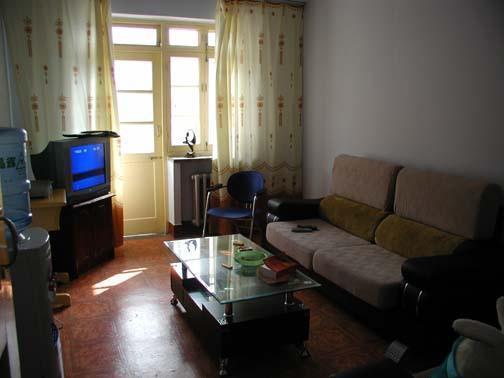How many chairs can be seen?
Give a very brief answer. 2. 